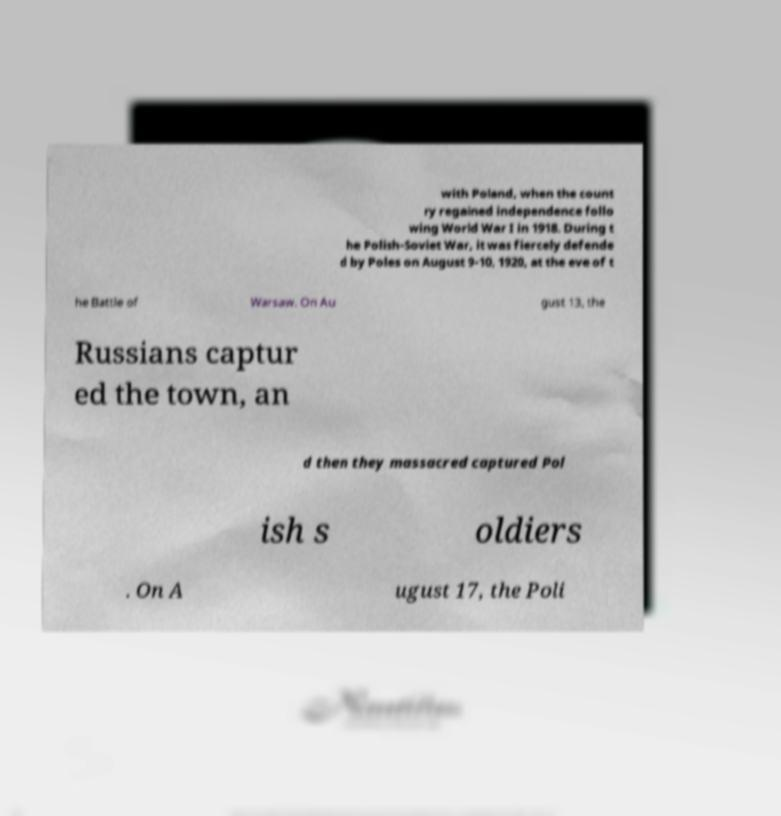Can you read and provide the text displayed in the image?This photo seems to have some interesting text. Can you extract and type it out for me? with Poland, when the count ry regained independence follo wing World War I in 1918. During t he Polish-Soviet War, it was fiercely defende d by Poles on August 9-10, 1920, at the eve of t he Battle of Warsaw. On Au gust 13, the Russians captur ed the town, an d then they massacred captured Pol ish s oldiers . On A ugust 17, the Poli 